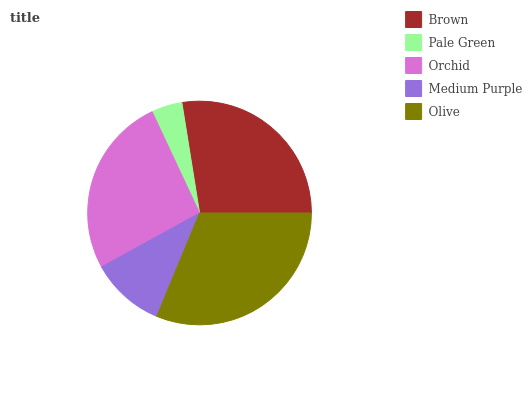Is Pale Green the minimum?
Answer yes or no. Yes. Is Olive the maximum?
Answer yes or no. Yes. Is Orchid the minimum?
Answer yes or no. No. Is Orchid the maximum?
Answer yes or no. No. Is Orchid greater than Pale Green?
Answer yes or no. Yes. Is Pale Green less than Orchid?
Answer yes or no. Yes. Is Pale Green greater than Orchid?
Answer yes or no. No. Is Orchid less than Pale Green?
Answer yes or no. No. Is Orchid the high median?
Answer yes or no. Yes. Is Orchid the low median?
Answer yes or no. Yes. Is Pale Green the high median?
Answer yes or no. No. Is Medium Purple the low median?
Answer yes or no. No. 